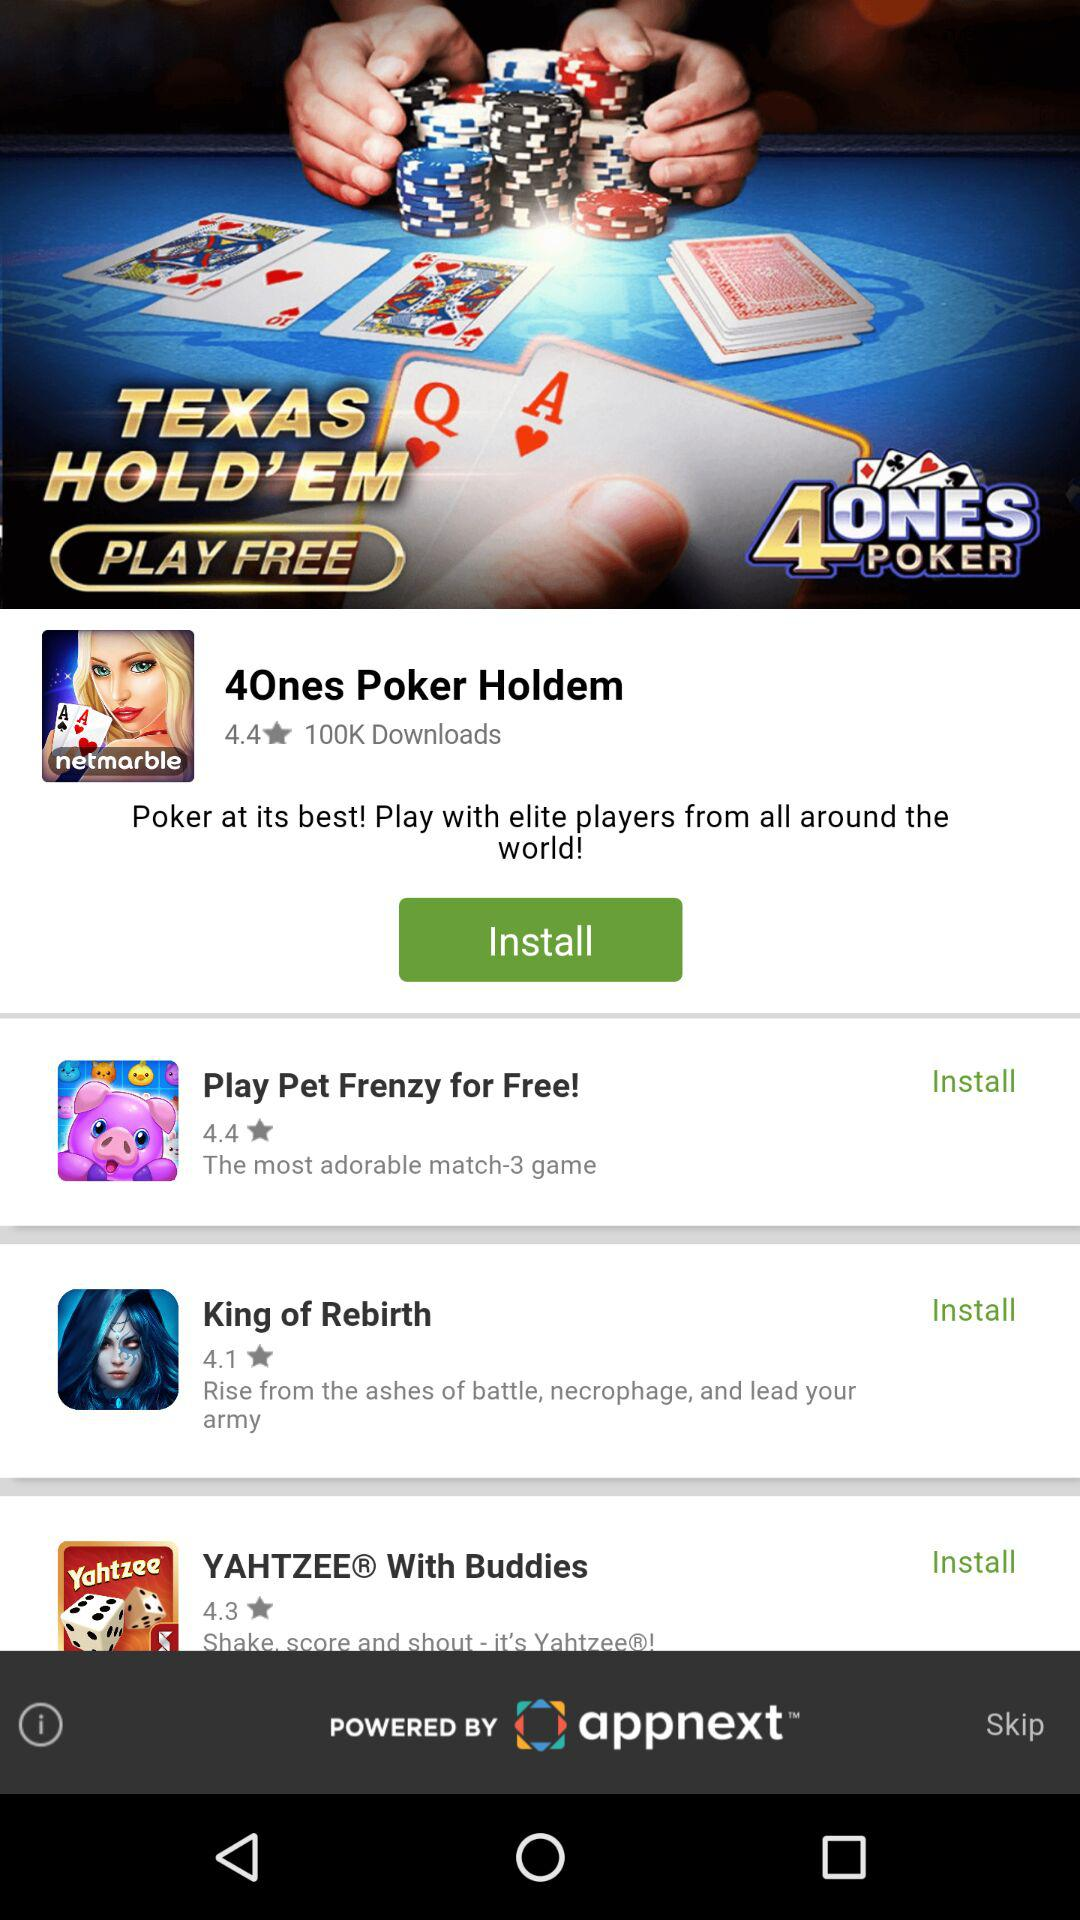What is the rating for "King of Rebirth"? The rating for "King of Rebirth" is 4.1. 